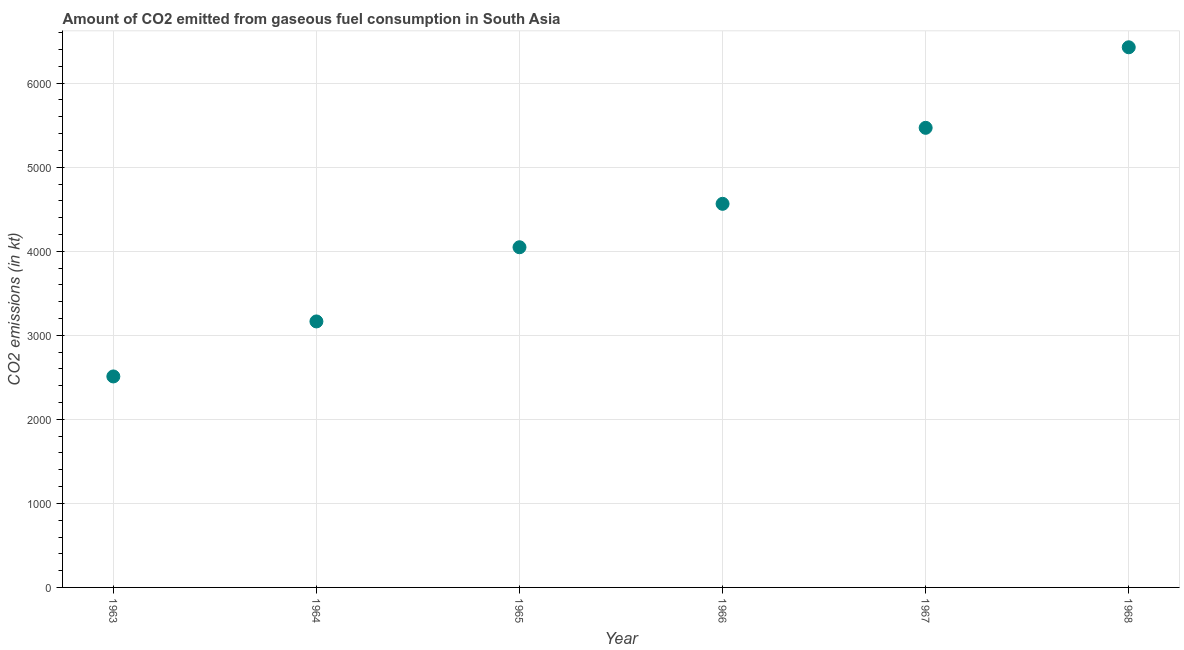What is the co2 emissions from gaseous fuel consumption in 1968?
Your answer should be compact. 6427.08. Across all years, what is the maximum co2 emissions from gaseous fuel consumption?
Give a very brief answer. 6427.08. Across all years, what is the minimum co2 emissions from gaseous fuel consumption?
Provide a short and direct response. 2510.45. In which year was the co2 emissions from gaseous fuel consumption maximum?
Give a very brief answer. 1968. In which year was the co2 emissions from gaseous fuel consumption minimum?
Provide a succinct answer. 1963. What is the sum of the co2 emissions from gaseous fuel consumption?
Offer a terse response. 2.62e+04. What is the difference between the co2 emissions from gaseous fuel consumption in 1966 and 1967?
Offer a very short reply. -904.28. What is the average co2 emissions from gaseous fuel consumption per year?
Offer a terse response. 4363.9. What is the median co2 emissions from gaseous fuel consumption?
Ensure brevity in your answer.  4306.08. In how many years, is the co2 emissions from gaseous fuel consumption greater than 1200 kt?
Offer a very short reply. 6. Do a majority of the years between 1967 and 1964 (inclusive) have co2 emissions from gaseous fuel consumption greater than 1000 kt?
Offer a very short reply. Yes. What is the ratio of the co2 emissions from gaseous fuel consumption in 1967 to that in 1968?
Keep it short and to the point. 0.85. Is the difference between the co2 emissions from gaseous fuel consumption in 1965 and 1967 greater than the difference between any two years?
Ensure brevity in your answer.  No. What is the difference between the highest and the second highest co2 emissions from gaseous fuel consumption?
Your answer should be compact. 958.35. Is the sum of the co2 emissions from gaseous fuel consumption in 1967 and 1968 greater than the maximum co2 emissions from gaseous fuel consumption across all years?
Give a very brief answer. Yes. What is the difference between the highest and the lowest co2 emissions from gaseous fuel consumption?
Your answer should be very brief. 3916.63. How many dotlines are there?
Provide a short and direct response. 1. How many years are there in the graph?
Ensure brevity in your answer.  6. What is the difference between two consecutive major ticks on the Y-axis?
Offer a terse response. 1000. Are the values on the major ticks of Y-axis written in scientific E-notation?
Provide a succinct answer. No. Does the graph contain grids?
Provide a succinct answer. Yes. What is the title of the graph?
Keep it short and to the point. Amount of CO2 emitted from gaseous fuel consumption in South Asia. What is the label or title of the X-axis?
Your answer should be very brief. Year. What is the label or title of the Y-axis?
Your response must be concise. CO2 emissions (in kt). What is the CO2 emissions (in kt) in 1963?
Ensure brevity in your answer.  2510.45. What is the CO2 emissions (in kt) in 1964?
Provide a short and direct response. 3164.97. What is the CO2 emissions (in kt) in 1965?
Provide a succinct answer. 4047.72. What is the CO2 emissions (in kt) in 1966?
Make the answer very short. 4564.45. What is the CO2 emissions (in kt) in 1967?
Ensure brevity in your answer.  5468.72. What is the CO2 emissions (in kt) in 1968?
Provide a succinct answer. 6427.08. What is the difference between the CO2 emissions (in kt) in 1963 and 1964?
Ensure brevity in your answer.  -654.52. What is the difference between the CO2 emissions (in kt) in 1963 and 1965?
Your response must be concise. -1537.27. What is the difference between the CO2 emissions (in kt) in 1963 and 1966?
Your answer should be very brief. -2054. What is the difference between the CO2 emissions (in kt) in 1963 and 1967?
Offer a terse response. -2958.28. What is the difference between the CO2 emissions (in kt) in 1963 and 1968?
Your response must be concise. -3916.63. What is the difference between the CO2 emissions (in kt) in 1964 and 1965?
Your response must be concise. -882.75. What is the difference between the CO2 emissions (in kt) in 1964 and 1966?
Offer a very short reply. -1399.48. What is the difference between the CO2 emissions (in kt) in 1964 and 1967?
Provide a succinct answer. -2303.75. What is the difference between the CO2 emissions (in kt) in 1964 and 1968?
Your response must be concise. -3262.11. What is the difference between the CO2 emissions (in kt) in 1965 and 1966?
Make the answer very short. -516.73. What is the difference between the CO2 emissions (in kt) in 1965 and 1967?
Provide a succinct answer. -1421.01. What is the difference between the CO2 emissions (in kt) in 1965 and 1968?
Your answer should be very brief. -2379.36. What is the difference between the CO2 emissions (in kt) in 1966 and 1967?
Offer a terse response. -904.28. What is the difference between the CO2 emissions (in kt) in 1966 and 1968?
Make the answer very short. -1862.63. What is the difference between the CO2 emissions (in kt) in 1967 and 1968?
Offer a very short reply. -958.35. What is the ratio of the CO2 emissions (in kt) in 1963 to that in 1964?
Provide a succinct answer. 0.79. What is the ratio of the CO2 emissions (in kt) in 1963 to that in 1965?
Your answer should be very brief. 0.62. What is the ratio of the CO2 emissions (in kt) in 1963 to that in 1966?
Ensure brevity in your answer.  0.55. What is the ratio of the CO2 emissions (in kt) in 1963 to that in 1967?
Provide a succinct answer. 0.46. What is the ratio of the CO2 emissions (in kt) in 1963 to that in 1968?
Give a very brief answer. 0.39. What is the ratio of the CO2 emissions (in kt) in 1964 to that in 1965?
Offer a very short reply. 0.78. What is the ratio of the CO2 emissions (in kt) in 1964 to that in 1966?
Make the answer very short. 0.69. What is the ratio of the CO2 emissions (in kt) in 1964 to that in 1967?
Offer a very short reply. 0.58. What is the ratio of the CO2 emissions (in kt) in 1964 to that in 1968?
Provide a short and direct response. 0.49. What is the ratio of the CO2 emissions (in kt) in 1965 to that in 1966?
Make the answer very short. 0.89. What is the ratio of the CO2 emissions (in kt) in 1965 to that in 1967?
Provide a short and direct response. 0.74. What is the ratio of the CO2 emissions (in kt) in 1965 to that in 1968?
Offer a very short reply. 0.63. What is the ratio of the CO2 emissions (in kt) in 1966 to that in 1967?
Provide a short and direct response. 0.83. What is the ratio of the CO2 emissions (in kt) in 1966 to that in 1968?
Provide a short and direct response. 0.71. What is the ratio of the CO2 emissions (in kt) in 1967 to that in 1968?
Offer a very short reply. 0.85. 